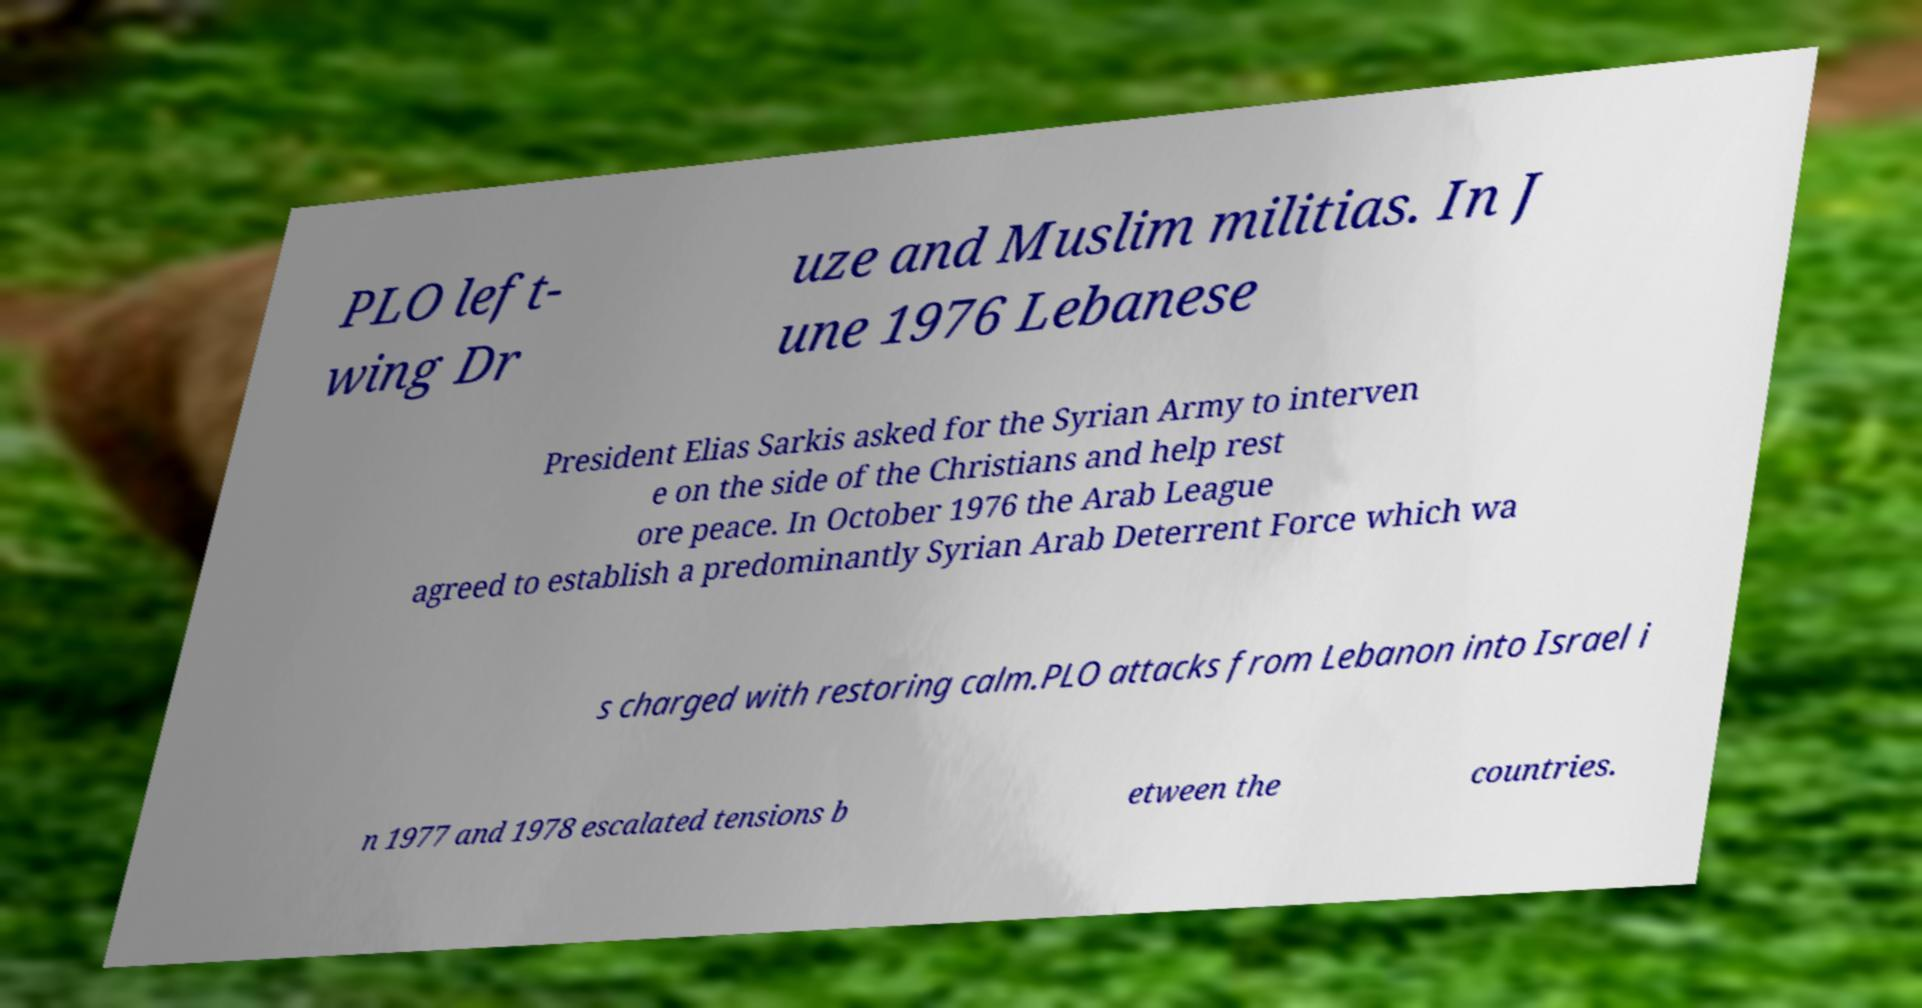Can you read and provide the text displayed in the image?This photo seems to have some interesting text. Can you extract and type it out for me? PLO left- wing Dr uze and Muslim militias. In J une 1976 Lebanese President Elias Sarkis asked for the Syrian Army to interven e on the side of the Christians and help rest ore peace. In October 1976 the Arab League agreed to establish a predominantly Syrian Arab Deterrent Force which wa s charged with restoring calm.PLO attacks from Lebanon into Israel i n 1977 and 1978 escalated tensions b etween the countries. 